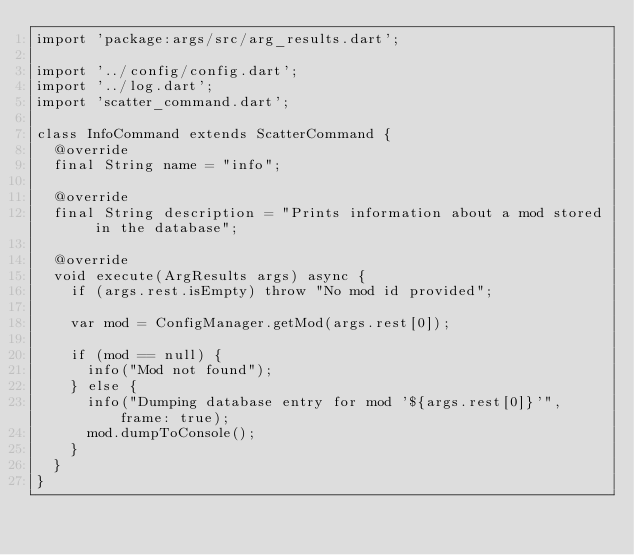<code> <loc_0><loc_0><loc_500><loc_500><_Dart_>import 'package:args/src/arg_results.dart';

import '../config/config.dart';
import '../log.dart';
import 'scatter_command.dart';

class InfoCommand extends ScatterCommand {
  @override
  final String name = "info";

  @override
  final String description = "Prints information about a mod stored in the database";

  @override
  void execute(ArgResults args) async {
    if (args.rest.isEmpty) throw "No mod id provided";

    var mod = ConfigManager.getMod(args.rest[0]);

    if (mod == null) {
      info("Mod not found");
    } else {
      info("Dumping database entry for mod '${args.rest[0]}'", frame: true);
      mod.dumpToConsole();
    }
  }
}
</code> 